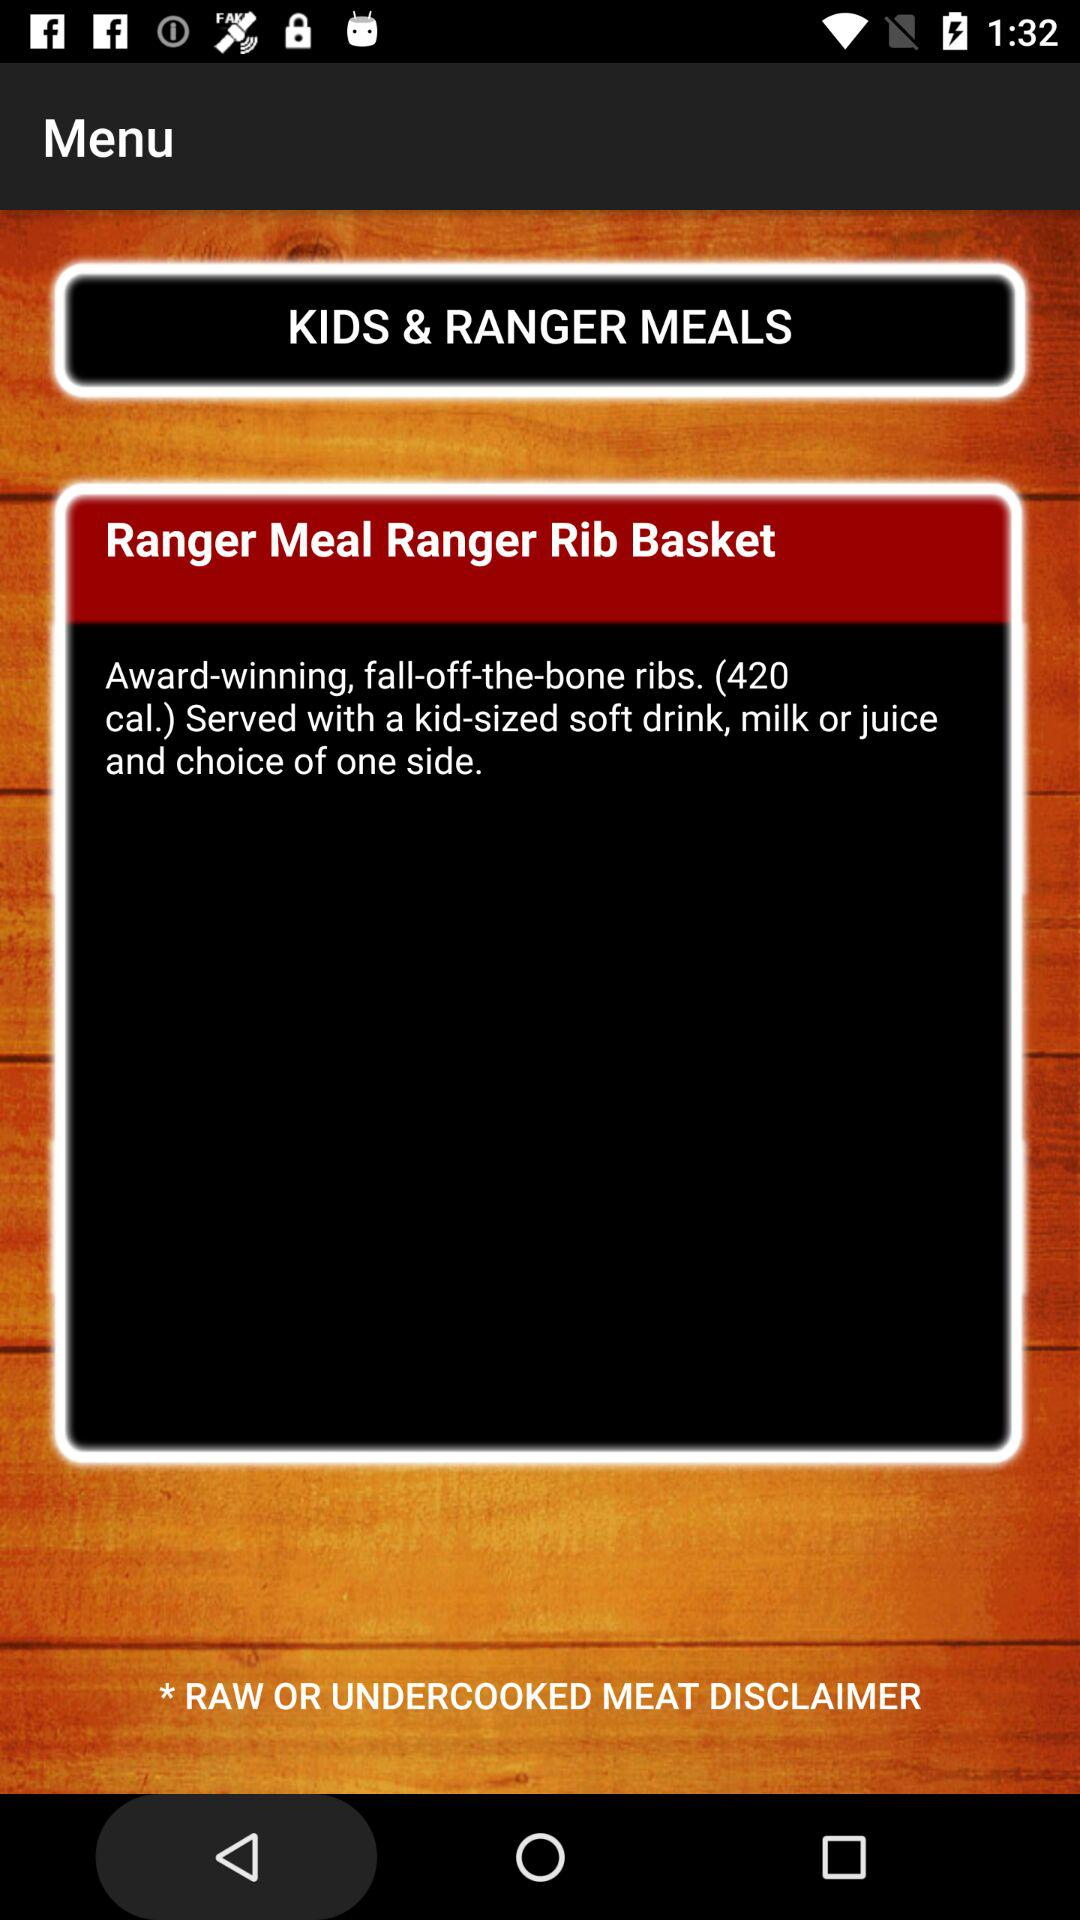How many calories are in the Ranger Meal Ranger Rib Basket?
Answer the question using a single word or phrase. 420 